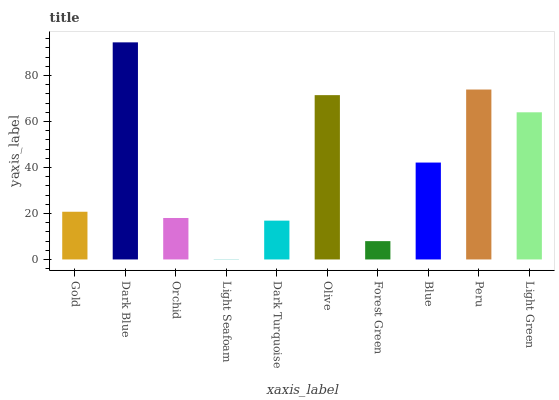Is Orchid the minimum?
Answer yes or no. No. Is Orchid the maximum?
Answer yes or no. No. Is Dark Blue greater than Orchid?
Answer yes or no. Yes. Is Orchid less than Dark Blue?
Answer yes or no. Yes. Is Orchid greater than Dark Blue?
Answer yes or no. No. Is Dark Blue less than Orchid?
Answer yes or no. No. Is Blue the high median?
Answer yes or no. Yes. Is Gold the low median?
Answer yes or no. Yes. Is Light Seafoam the high median?
Answer yes or no. No. Is Forest Green the low median?
Answer yes or no. No. 